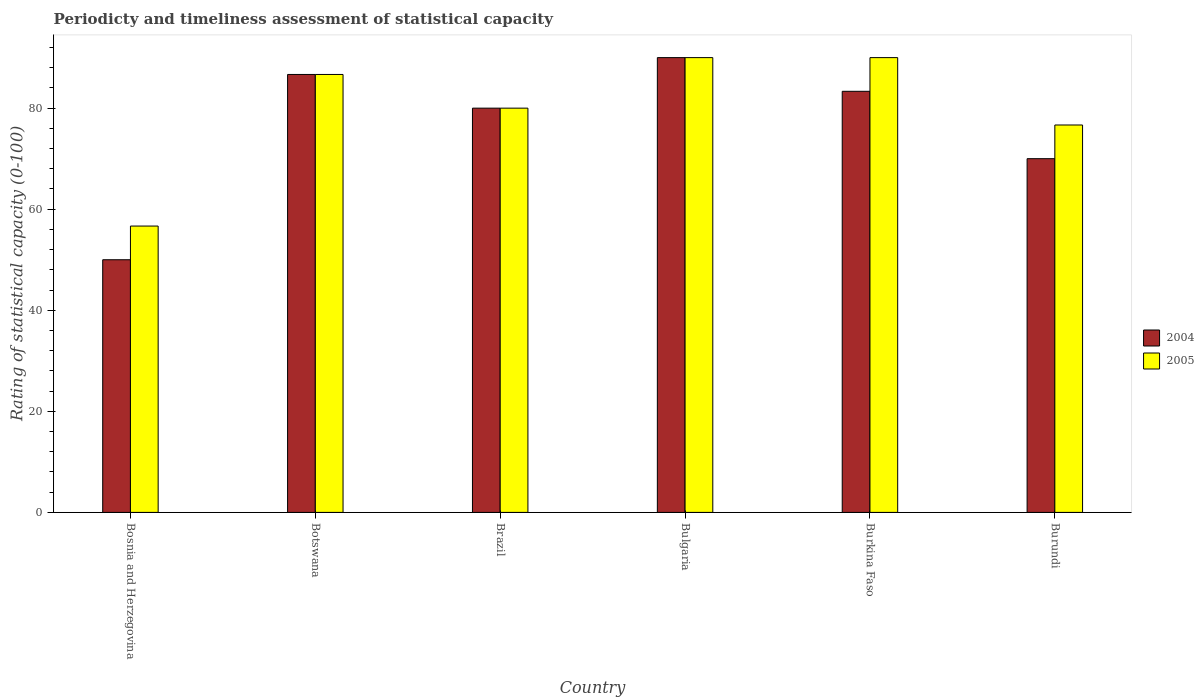How many groups of bars are there?
Provide a succinct answer. 6. Are the number of bars per tick equal to the number of legend labels?
Offer a terse response. Yes. Are the number of bars on each tick of the X-axis equal?
Make the answer very short. Yes. What is the rating of statistical capacity in 2004 in Burkina Faso?
Your answer should be compact. 83.33. Across all countries, what is the maximum rating of statistical capacity in 2005?
Give a very brief answer. 90. Across all countries, what is the minimum rating of statistical capacity in 2005?
Make the answer very short. 56.67. In which country was the rating of statistical capacity in 2005 minimum?
Give a very brief answer. Bosnia and Herzegovina. What is the total rating of statistical capacity in 2004 in the graph?
Offer a very short reply. 460. What is the difference between the rating of statistical capacity in 2005 in Brazil and that in Burundi?
Ensure brevity in your answer.  3.33. What is the difference between the rating of statistical capacity in 2005 in Burkina Faso and the rating of statistical capacity in 2004 in Brazil?
Give a very brief answer. 10. What is the average rating of statistical capacity in 2005 per country?
Give a very brief answer. 80. In how many countries, is the rating of statistical capacity in 2004 greater than 4?
Offer a very short reply. 6. What is the ratio of the rating of statistical capacity in 2004 in Brazil to that in Burundi?
Your answer should be compact. 1.14. What is the difference between the highest and the second highest rating of statistical capacity in 2005?
Your answer should be compact. 3.33. What is the difference between the highest and the lowest rating of statistical capacity in 2004?
Offer a very short reply. 40. In how many countries, is the rating of statistical capacity in 2004 greater than the average rating of statistical capacity in 2004 taken over all countries?
Give a very brief answer. 4. Is the sum of the rating of statistical capacity in 2005 in Brazil and Bulgaria greater than the maximum rating of statistical capacity in 2004 across all countries?
Your answer should be very brief. Yes. What does the 1st bar from the right in Bulgaria represents?
Make the answer very short. 2005. Are all the bars in the graph horizontal?
Provide a short and direct response. No. How many countries are there in the graph?
Your answer should be compact. 6. Are the values on the major ticks of Y-axis written in scientific E-notation?
Give a very brief answer. No. Does the graph contain grids?
Provide a short and direct response. No. How many legend labels are there?
Offer a terse response. 2. How are the legend labels stacked?
Your answer should be very brief. Vertical. What is the title of the graph?
Give a very brief answer. Periodicty and timeliness assessment of statistical capacity. Does "1989" appear as one of the legend labels in the graph?
Provide a succinct answer. No. What is the label or title of the X-axis?
Give a very brief answer. Country. What is the label or title of the Y-axis?
Ensure brevity in your answer.  Rating of statistical capacity (0-100). What is the Rating of statistical capacity (0-100) in 2005 in Bosnia and Herzegovina?
Provide a short and direct response. 56.67. What is the Rating of statistical capacity (0-100) in 2004 in Botswana?
Make the answer very short. 86.67. What is the Rating of statistical capacity (0-100) of 2005 in Botswana?
Give a very brief answer. 86.67. What is the Rating of statistical capacity (0-100) in 2004 in Brazil?
Make the answer very short. 80. What is the Rating of statistical capacity (0-100) of 2004 in Bulgaria?
Offer a very short reply. 90. What is the Rating of statistical capacity (0-100) of 2004 in Burkina Faso?
Offer a terse response. 83.33. What is the Rating of statistical capacity (0-100) in 2005 in Burundi?
Make the answer very short. 76.67. Across all countries, what is the maximum Rating of statistical capacity (0-100) of 2004?
Offer a very short reply. 90. Across all countries, what is the maximum Rating of statistical capacity (0-100) of 2005?
Your response must be concise. 90. Across all countries, what is the minimum Rating of statistical capacity (0-100) of 2005?
Your answer should be compact. 56.67. What is the total Rating of statistical capacity (0-100) of 2004 in the graph?
Provide a short and direct response. 460. What is the total Rating of statistical capacity (0-100) in 2005 in the graph?
Offer a very short reply. 480. What is the difference between the Rating of statistical capacity (0-100) in 2004 in Bosnia and Herzegovina and that in Botswana?
Offer a very short reply. -36.67. What is the difference between the Rating of statistical capacity (0-100) in 2005 in Bosnia and Herzegovina and that in Botswana?
Offer a terse response. -30. What is the difference between the Rating of statistical capacity (0-100) in 2005 in Bosnia and Herzegovina and that in Brazil?
Offer a very short reply. -23.33. What is the difference between the Rating of statistical capacity (0-100) of 2004 in Bosnia and Herzegovina and that in Bulgaria?
Make the answer very short. -40. What is the difference between the Rating of statistical capacity (0-100) in 2005 in Bosnia and Herzegovina and that in Bulgaria?
Ensure brevity in your answer.  -33.33. What is the difference between the Rating of statistical capacity (0-100) of 2004 in Bosnia and Herzegovina and that in Burkina Faso?
Provide a succinct answer. -33.33. What is the difference between the Rating of statistical capacity (0-100) of 2005 in Bosnia and Herzegovina and that in Burkina Faso?
Make the answer very short. -33.33. What is the difference between the Rating of statistical capacity (0-100) of 2004 in Bosnia and Herzegovina and that in Burundi?
Your answer should be very brief. -20. What is the difference between the Rating of statistical capacity (0-100) in 2005 in Bosnia and Herzegovina and that in Burundi?
Your answer should be very brief. -20. What is the difference between the Rating of statistical capacity (0-100) in 2004 in Botswana and that in Burkina Faso?
Your answer should be very brief. 3.33. What is the difference between the Rating of statistical capacity (0-100) of 2004 in Botswana and that in Burundi?
Provide a short and direct response. 16.67. What is the difference between the Rating of statistical capacity (0-100) of 2004 in Brazil and that in Bulgaria?
Provide a short and direct response. -10. What is the difference between the Rating of statistical capacity (0-100) of 2005 in Brazil and that in Burkina Faso?
Make the answer very short. -10. What is the difference between the Rating of statistical capacity (0-100) of 2004 in Brazil and that in Burundi?
Keep it short and to the point. 10. What is the difference between the Rating of statistical capacity (0-100) of 2004 in Bulgaria and that in Burkina Faso?
Provide a short and direct response. 6.67. What is the difference between the Rating of statistical capacity (0-100) in 2004 in Bulgaria and that in Burundi?
Provide a short and direct response. 20. What is the difference between the Rating of statistical capacity (0-100) in 2005 in Bulgaria and that in Burundi?
Give a very brief answer. 13.33. What is the difference between the Rating of statistical capacity (0-100) in 2004 in Burkina Faso and that in Burundi?
Your answer should be very brief. 13.33. What is the difference between the Rating of statistical capacity (0-100) in 2005 in Burkina Faso and that in Burundi?
Offer a very short reply. 13.33. What is the difference between the Rating of statistical capacity (0-100) of 2004 in Bosnia and Herzegovina and the Rating of statistical capacity (0-100) of 2005 in Botswana?
Your answer should be very brief. -36.67. What is the difference between the Rating of statistical capacity (0-100) in 2004 in Bosnia and Herzegovina and the Rating of statistical capacity (0-100) in 2005 in Burkina Faso?
Give a very brief answer. -40. What is the difference between the Rating of statistical capacity (0-100) in 2004 in Bosnia and Herzegovina and the Rating of statistical capacity (0-100) in 2005 in Burundi?
Give a very brief answer. -26.67. What is the difference between the Rating of statistical capacity (0-100) of 2004 in Botswana and the Rating of statistical capacity (0-100) of 2005 in Brazil?
Provide a short and direct response. 6.67. What is the difference between the Rating of statistical capacity (0-100) of 2004 in Botswana and the Rating of statistical capacity (0-100) of 2005 in Bulgaria?
Offer a terse response. -3.33. What is the difference between the Rating of statistical capacity (0-100) in 2004 in Brazil and the Rating of statistical capacity (0-100) in 2005 in Bulgaria?
Give a very brief answer. -10. What is the difference between the Rating of statistical capacity (0-100) of 2004 in Brazil and the Rating of statistical capacity (0-100) of 2005 in Burkina Faso?
Your response must be concise. -10. What is the difference between the Rating of statistical capacity (0-100) of 2004 in Brazil and the Rating of statistical capacity (0-100) of 2005 in Burundi?
Give a very brief answer. 3.33. What is the difference between the Rating of statistical capacity (0-100) in 2004 in Bulgaria and the Rating of statistical capacity (0-100) in 2005 in Burundi?
Your answer should be compact. 13.33. What is the difference between the Rating of statistical capacity (0-100) in 2004 in Burkina Faso and the Rating of statistical capacity (0-100) in 2005 in Burundi?
Make the answer very short. 6.67. What is the average Rating of statistical capacity (0-100) of 2004 per country?
Ensure brevity in your answer.  76.67. What is the difference between the Rating of statistical capacity (0-100) of 2004 and Rating of statistical capacity (0-100) of 2005 in Bosnia and Herzegovina?
Offer a terse response. -6.67. What is the difference between the Rating of statistical capacity (0-100) of 2004 and Rating of statistical capacity (0-100) of 2005 in Brazil?
Give a very brief answer. 0. What is the difference between the Rating of statistical capacity (0-100) of 2004 and Rating of statistical capacity (0-100) of 2005 in Bulgaria?
Give a very brief answer. 0. What is the difference between the Rating of statistical capacity (0-100) of 2004 and Rating of statistical capacity (0-100) of 2005 in Burkina Faso?
Ensure brevity in your answer.  -6.67. What is the difference between the Rating of statistical capacity (0-100) in 2004 and Rating of statistical capacity (0-100) in 2005 in Burundi?
Make the answer very short. -6.67. What is the ratio of the Rating of statistical capacity (0-100) of 2004 in Bosnia and Herzegovina to that in Botswana?
Offer a terse response. 0.58. What is the ratio of the Rating of statistical capacity (0-100) in 2005 in Bosnia and Herzegovina to that in Botswana?
Your answer should be very brief. 0.65. What is the ratio of the Rating of statistical capacity (0-100) in 2004 in Bosnia and Herzegovina to that in Brazil?
Give a very brief answer. 0.62. What is the ratio of the Rating of statistical capacity (0-100) of 2005 in Bosnia and Herzegovina to that in Brazil?
Offer a very short reply. 0.71. What is the ratio of the Rating of statistical capacity (0-100) of 2004 in Bosnia and Herzegovina to that in Bulgaria?
Offer a very short reply. 0.56. What is the ratio of the Rating of statistical capacity (0-100) in 2005 in Bosnia and Herzegovina to that in Bulgaria?
Keep it short and to the point. 0.63. What is the ratio of the Rating of statistical capacity (0-100) of 2005 in Bosnia and Herzegovina to that in Burkina Faso?
Your answer should be compact. 0.63. What is the ratio of the Rating of statistical capacity (0-100) of 2005 in Bosnia and Herzegovina to that in Burundi?
Provide a short and direct response. 0.74. What is the ratio of the Rating of statistical capacity (0-100) of 2005 in Botswana to that in Brazil?
Your answer should be compact. 1.08. What is the ratio of the Rating of statistical capacity (0-100) in 2004 in Botswana to that in Bulgaria?
Ensure brevity in your answer.  0.96. What is the ratio of the Rating of statistical capacity (0-100) in 2005 in Botswana to that in Bulgaria?
Your response must be concise. 0.96. What is the ratio of the Rating of statistical capacity (0-100) in 2005 in Botswana to that in Burkina Faso?
Provide a short and direct response. 0.96. What is the ratio of the Rating of statistical capacity (0-100) in 2004 in Botswana to that in Burundi?
Provide a succinct answer. 1.24. What is the ratio of the Rating of statistical capacity (0-100) in 2005 in Botswana to that in Burundi?
Your answer should be very brief. 1.13. What is the ratio of the Rating of statistical capacity (0-100) of 2004 in Brazil to that in Burkina Faso?
Give a very brief answer. 0.96. What is the ratio of the Rating of statistical capacity (0-100) in 2005 in Brazil to that in Burundi?
Provide a succinct answer. 1.04. What is the ratio of the Rating of statistical capacity (0-100) of 2005 in Bulgaria to that in Burundi?
Make the answer very short. 1.17. What is the ratio of the Rating of statistical capacity (0-100) of 2004 in Burkina Faso to that in Burundi?
Your response must be concise. 1.19. What is the ratio of the Rating of statistical capacity (0-100) of 2005 in Burkina Faso to that in Burundi?
Your answer should be compact. 1.17. What is the difference between the highest and the lowest Rating of statistical capacity (0-100) of 2004?
Offer a terse response. 40. What is the difference between the highest and the lowest Rating of statistical capacity (0-100) in 2005?
Your answer should be compact. 33.33. 